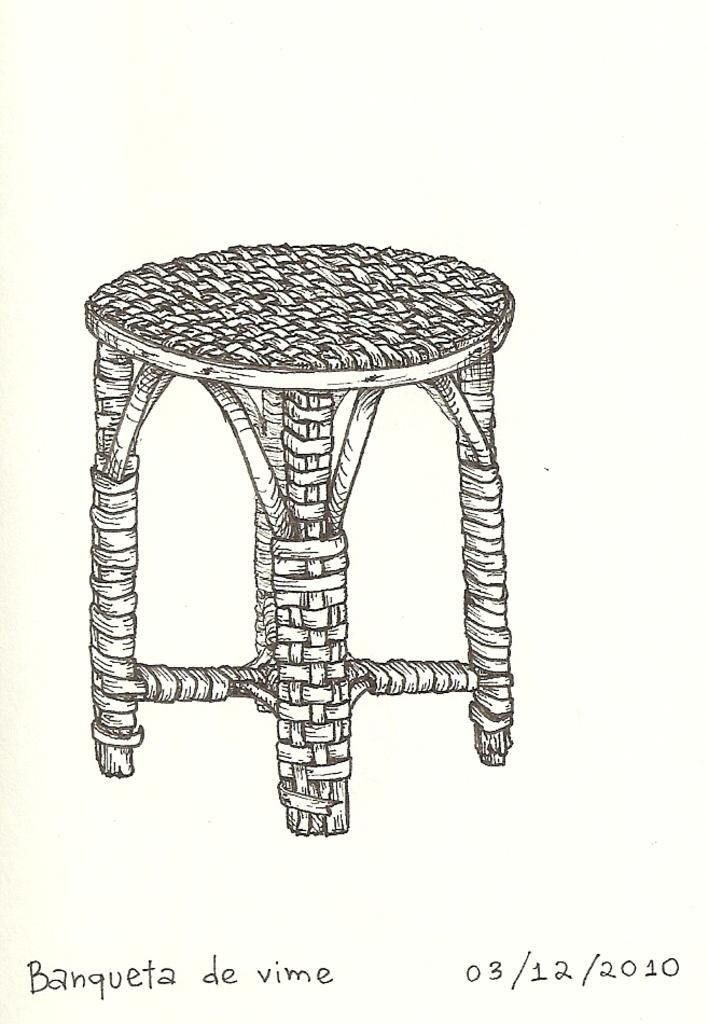What can be found at the bottom of the image? There is text at the bottom of the image. What is the main subject of the image? The main subject of the image is a diagram of a stool. What does the minister look like in the image? There is no minister present in the image. How much waste is visible in the image? There is no waste visible in the image; it features text and a diagram of a stool. 